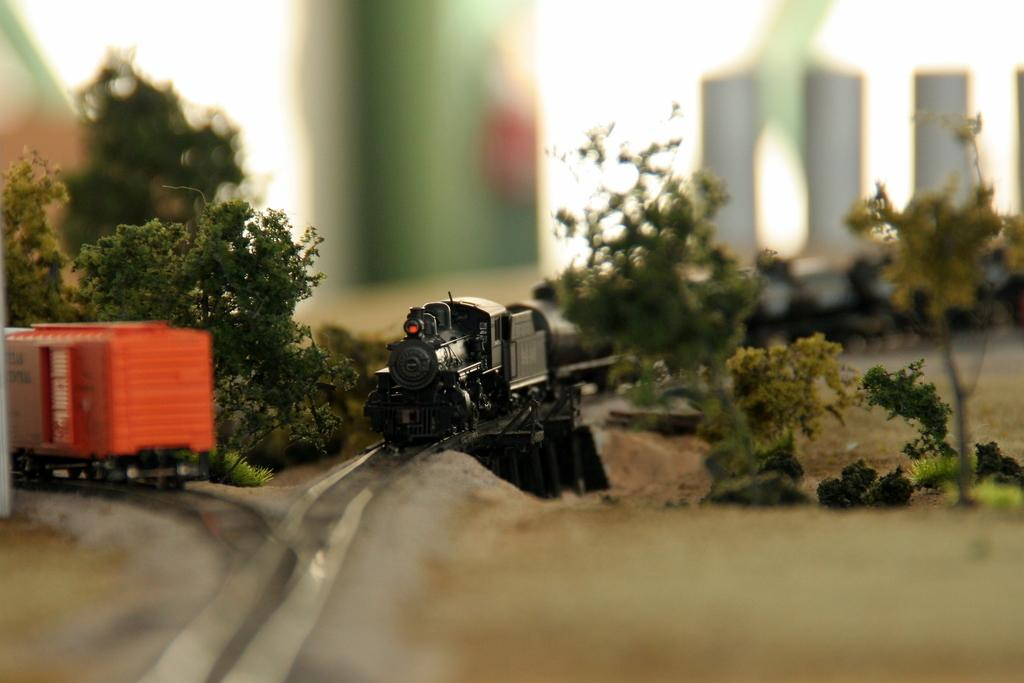What type of toy is present in the image? There are toy trains in the image. How are the toy trains arranged in the image? The toy trains are on toy railway tracks. What type of natural elements can be seen in the image? There are trees visible in the image. Can you describe the background of the image? The background of the image is blurred. What type of beam is holding up the toy trains in the image? There is no beam present in the image; the toy trains are on toy railway tracks. How many quinces are visible in the image? There are no quinces present in the image. 